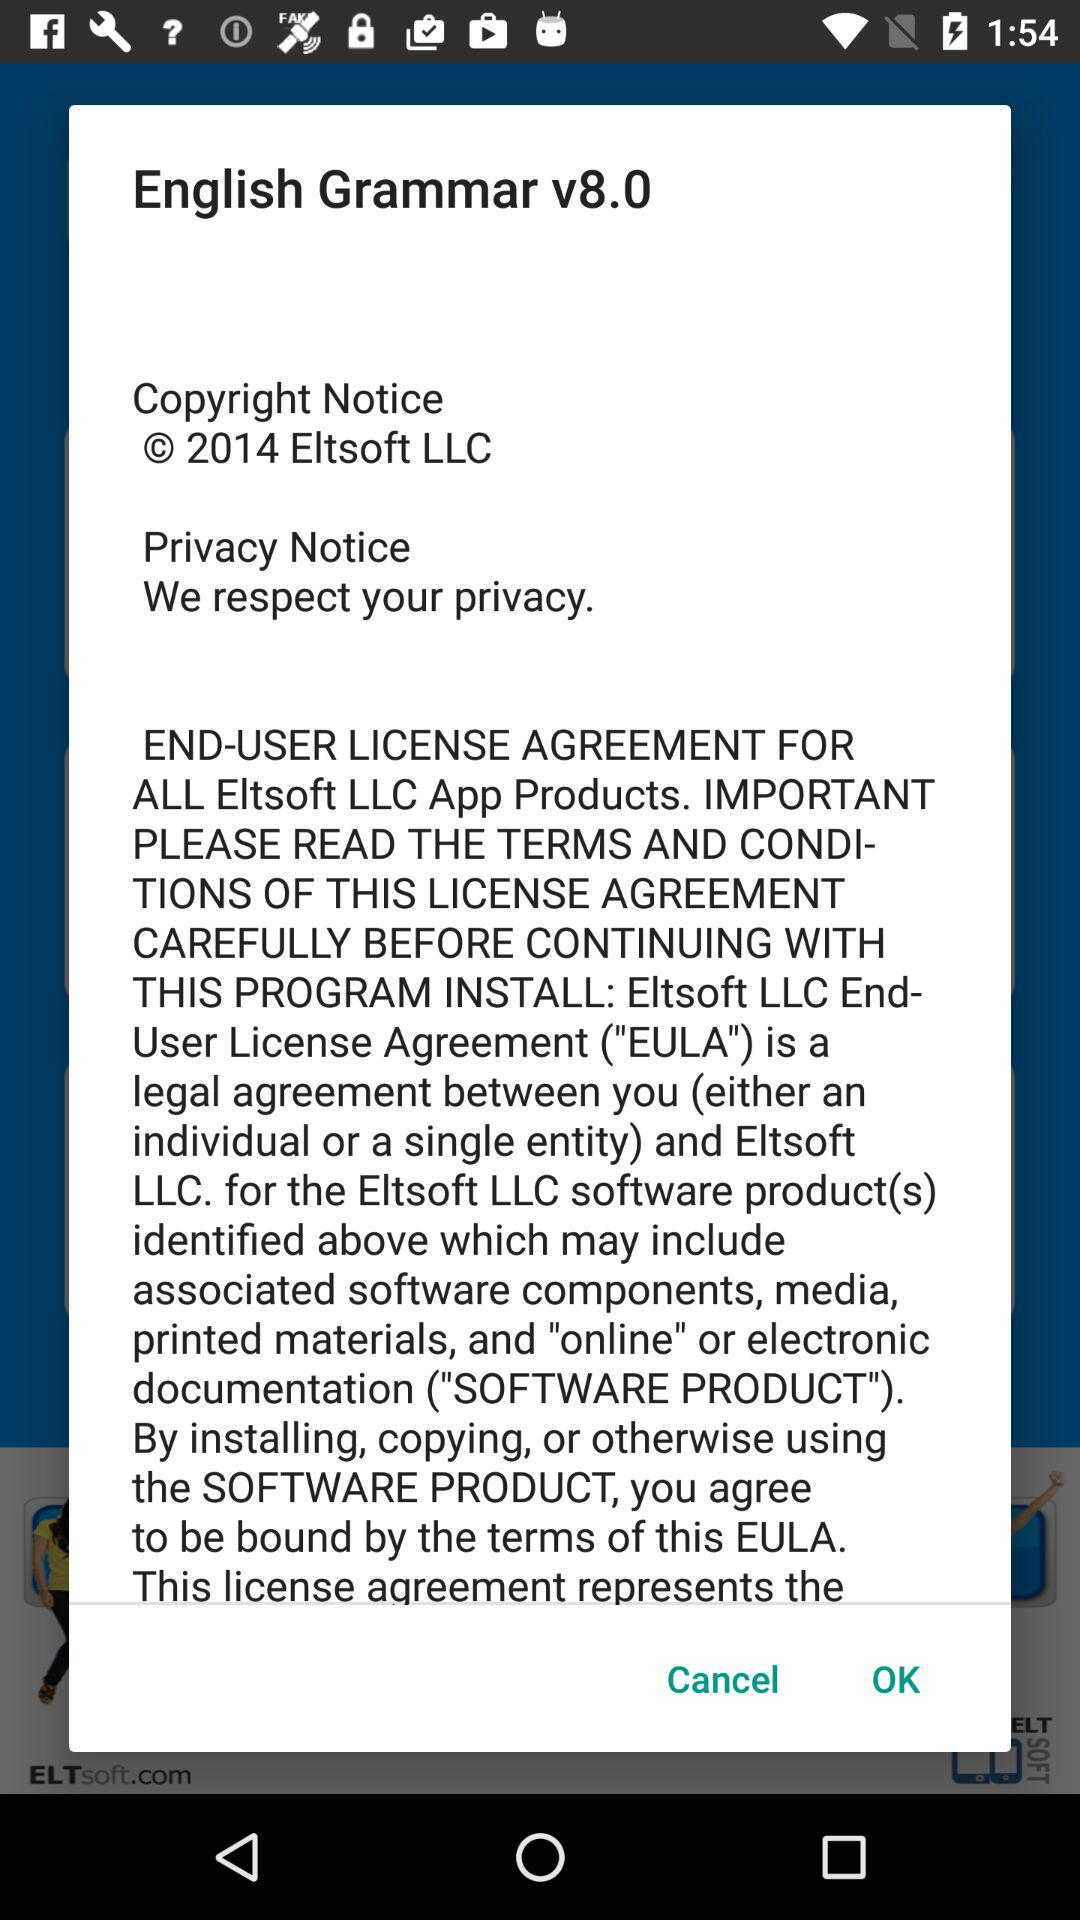How many text elements are there on this screen?
Answer the question using a single word or phrase. 4 